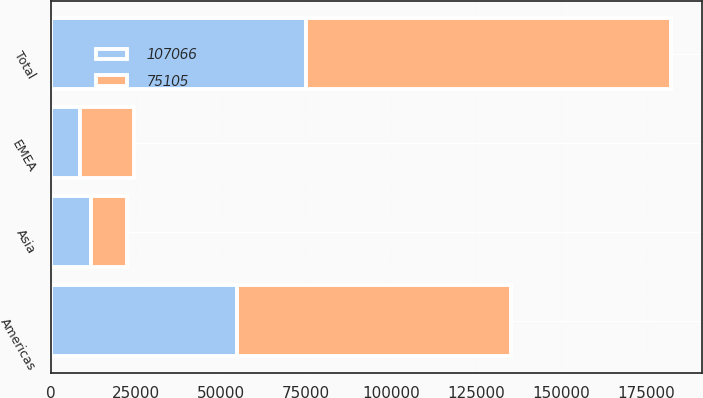Convert chart to OTSL. <chart><loc_0><loc_0><loc_500><loc_500><stacked_bar_chart><ecel><fcel>Americas<fcel>EMEA<fcel>Asia<fcel>Total<nl><fcel>75105<fcel>80381<fcel>16099<fcel>10586<fcel>107066<nl><fcel>107066<fcel>54846<fcel>8496<fcel>11763<fcel>75105<nl></chart> 